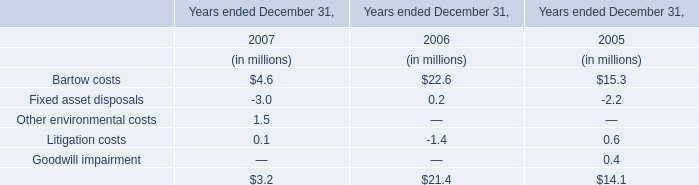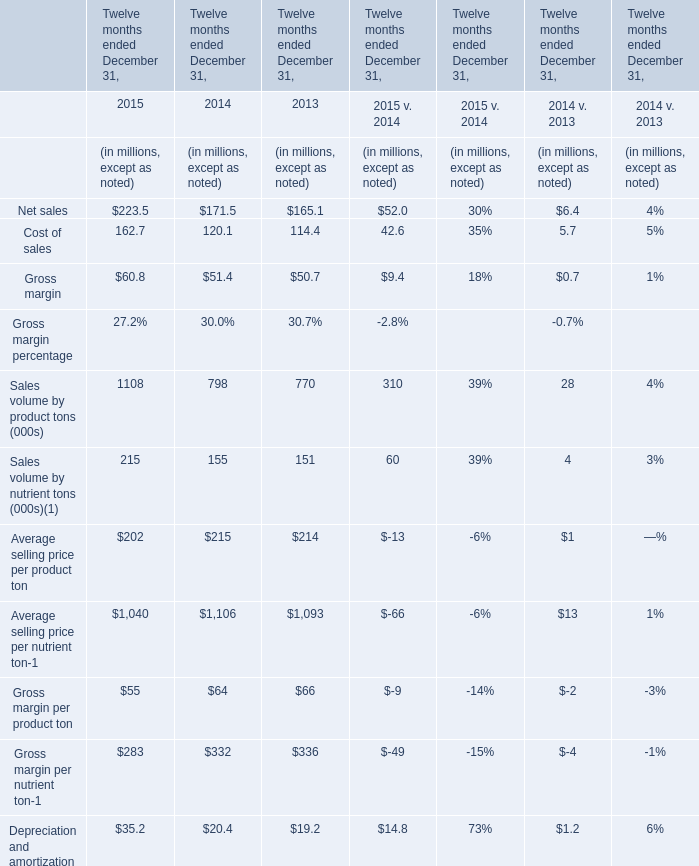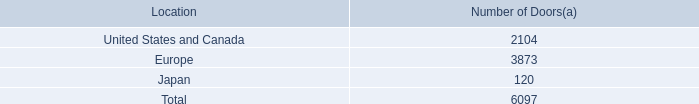What is the sum of Cost of sales in 2014 and Litigation costs in 2005? (in million) 
Computations: (120.1 + 0.6)
Answer: 120.7. What was the total amount of the Depreciation and amortization,Net sales,and Cost of sales in the year where Gross margin per nutrient ton is greater than 333 ? (in million) 
Computations: ((19.2 + 165.1) + 114.4)
Answer: 298.7. 